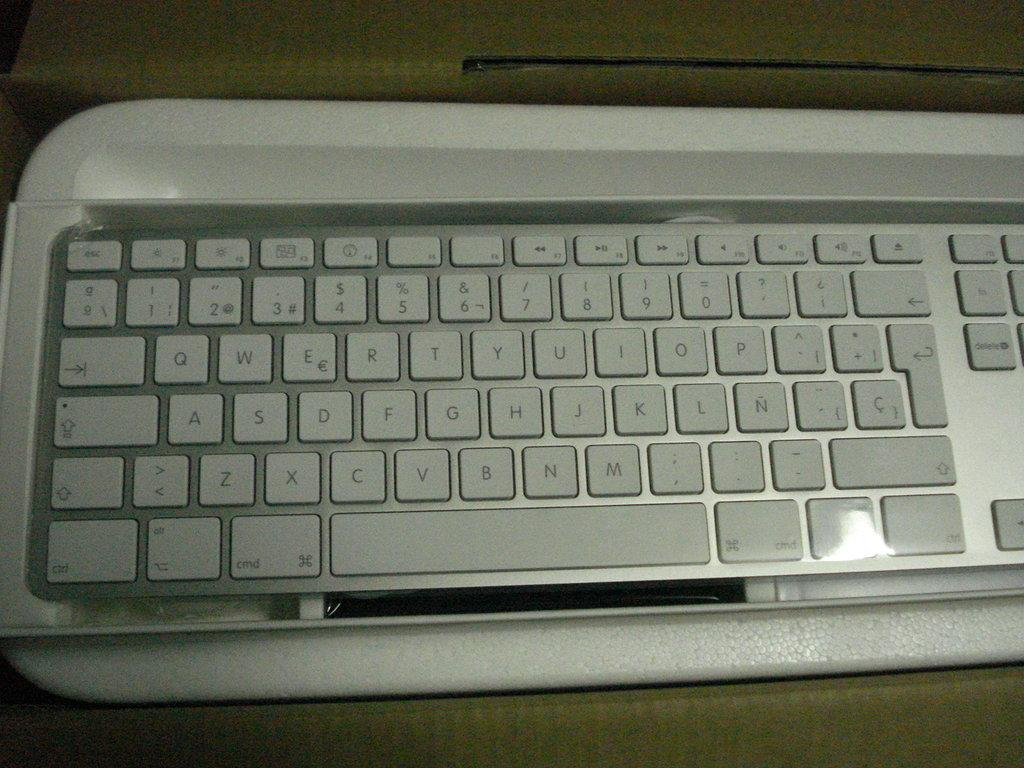<image>
Create a compact narrative representing the image presented. A white keyboard has a cmd key just below the z and x keys. 